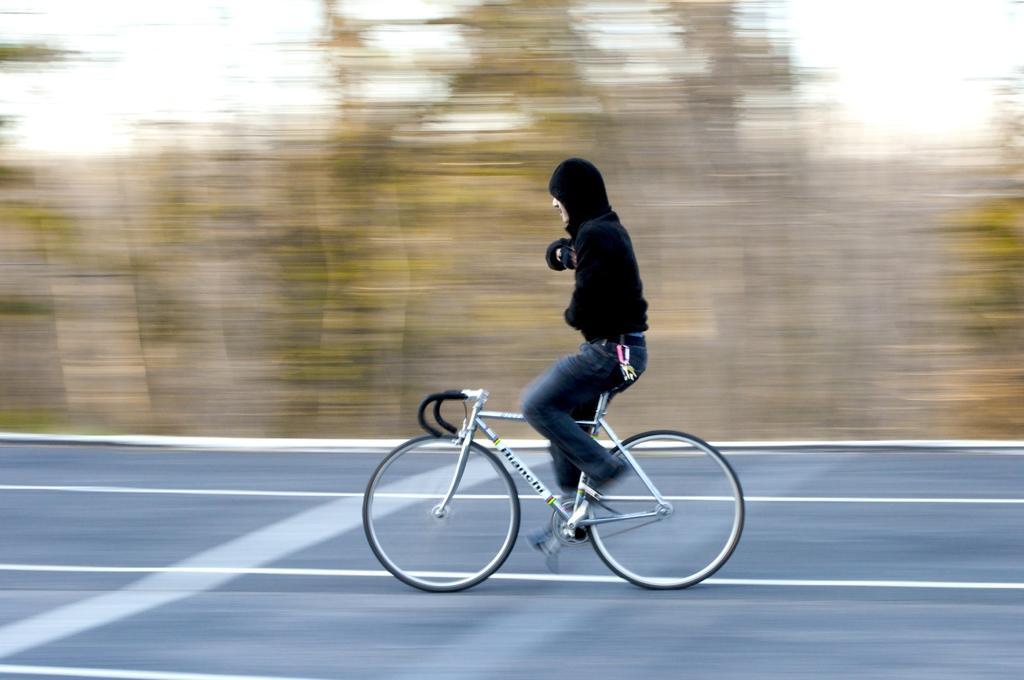In one or two sentences, can you explain what this image depicts? In this image we can see a person riding bicycle on the road. In the background there are trees and sky. 